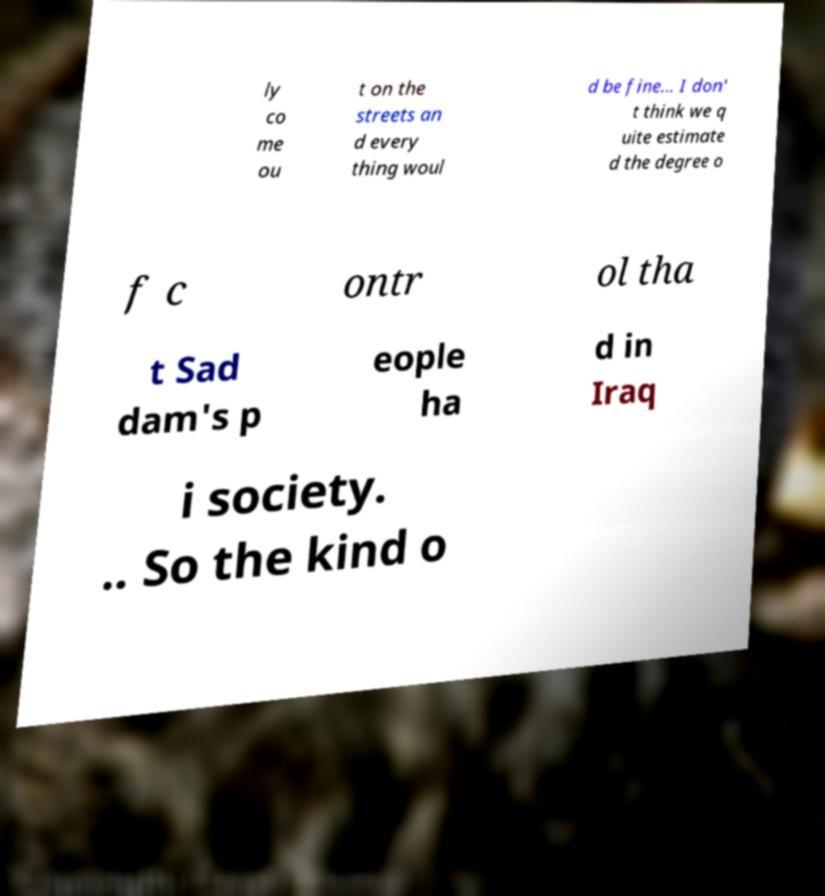Could you extract and type out the text from this image? ly co me ou t on the streets an d every thing woul d be fine... I don' t think we q uite estimate d the degree o f c ontr ol tha t Sad dam's p eople ha d in Iraq i society. .. So the kind o 